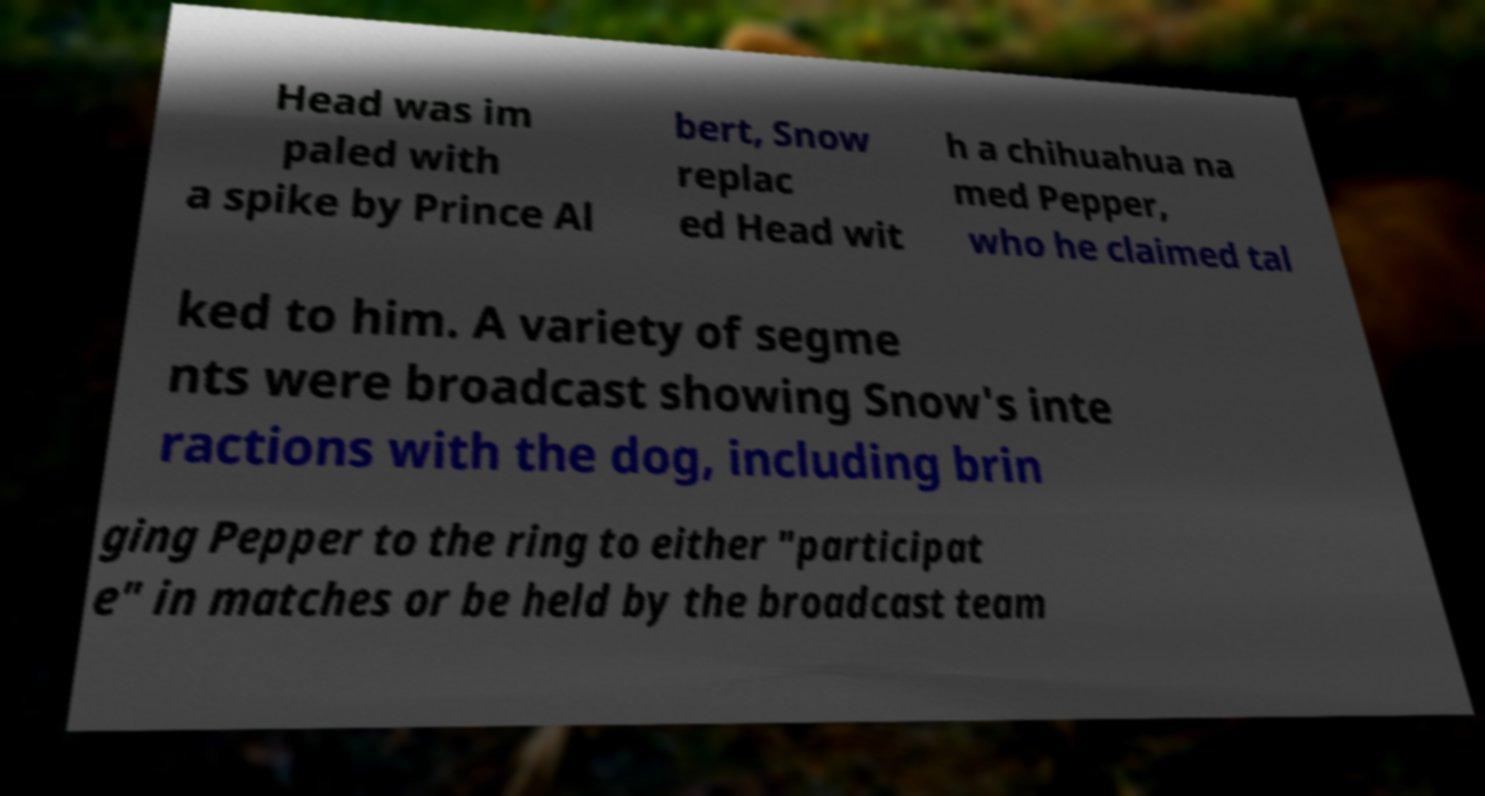Can you read and provide the text displayed in the image?This photo seems to have some interesting text. Can you extract and type it out for me? Head was im paled with a spike by Prince Al bert, Snow replac ed Head wit h a chihuahua na med Pepper, who he claimed tal ked to him. A variety of segme nts were broadcast showing Snow's inte ractions with the dog, including brin ging Pepper to the ring to either "participat e" in matches or be held by the broadcast team 